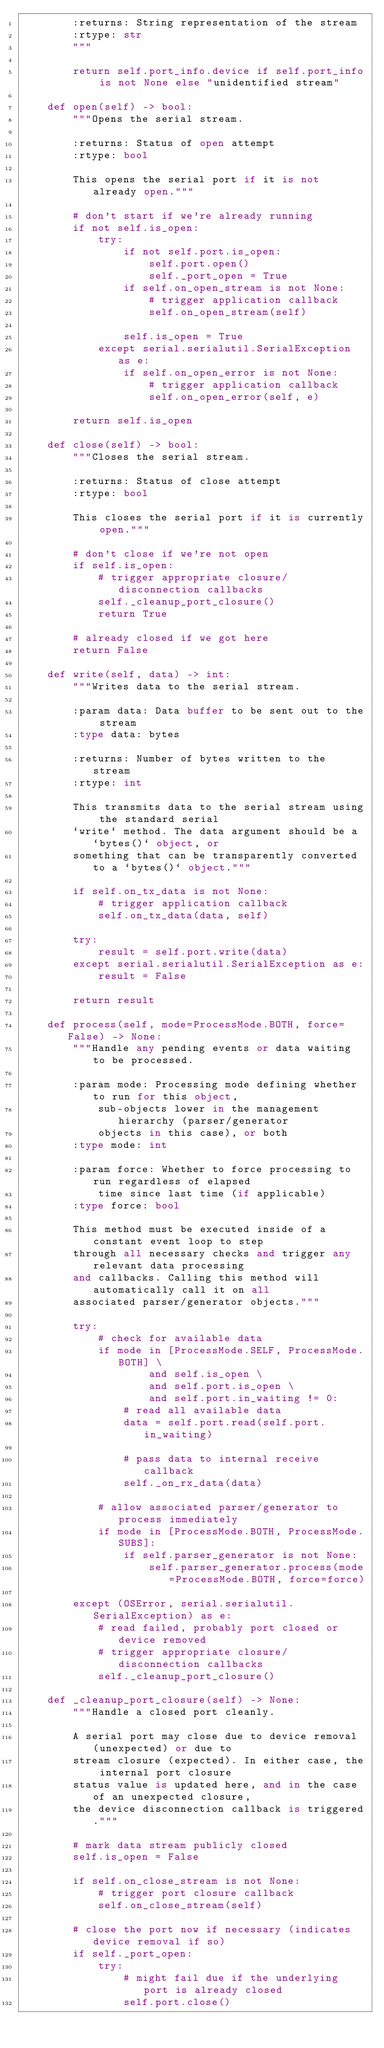Convert code to text. <code><loc_0><loc_0><loc_500><loc_500><_Python_>        :returns: String representation of the stream
        :rtype: str
        """

        return self.port_info.device if self.port_info is not None else "unidentified stream"

    def open(self) -> bool:
        """Opens the serial stream.

        :returns: Status of open attempt
        :rtype: bool

        This opens the serial port if it is not already open."""

        # don't start if we're already running
        if not self.is_open:
            try:
                if not self.port.is_open:
                    self.port.open()
                    self._port_open = True
                if self.on_open_stream is not None:
                    # trigger application callback
                    self.on_open_stream(self)

                self.is_open = True
            except serial.serialutil.SerialException as e:
                if self.on_open_error is not None:
                    # trigger application callback
                    self.on_open_error(self, e)

        return self.is_open

    def close(self) -> bool:
        """Closes the serial stream.

        :returns: Status of close attempt
        :rtype: bool

        This closes the serial port if it is currently open."""

        # don't close if we're not open
        if self.is_open:
            # trigger appropriate closure/disconnection callbacks
            self._cleanup_port_closure()
            return True

        # already closed if we got here
        return False

    def write(self, data) -> int:
        """Writes data to the serial stream.

        :param data: Data buffer to be sent out to the stream
        :type data: bytes

        :returns: Number of bytes written to the stream
        :rtype: int

        This transmits data to the serial stream using the standard serial
        `write` method. The data argument should be a `bytes()` object, or
        something that can be transparently converted to a `bytes()` object."""

        if self.on_tx_data is not None:
            # trigger application callback
            self.on_tx_data(data, self)

        try:
            result = self.port.write(data)
        except serial.serialutil.SerialException as e:
            result = False

        return result

    def process(self, mode=ProcessMode.BOTH, force=False) -> None:
        """Handle any pending events or data waiting to be processed.

        :param mode: Processing mode defining whether to run for this object,
            sub-objects lower in the management hierarchy (parser/generator
            objects in this case), or both
        :type mode: int

        :param force: Whether to force processing to run regardless of elapsed
            time since last time (if applicable)
        :type force: bool

        This method must be executed inside of a constant event loop to step
        through all necessary checks and trigger any relevant data processing
        and callbacks. Calling this method will automatically call it on all
        associated parser/generator objects."""

        try:
            # check for available data
            if mode in [ProcessMode.SELF, ProcessMode.BOTH] \
                    and self.is_open \
                    and self.port.is_open \
                    and self.port.in_waiting != 0:
                # read all available data
                data = self.port.read(self.port.in_waiting)

                # pass data to internal receive callback
                self._on_rx_data(data)

            # allow associated parser/generator to process immediately
            if mode in [ProcessMode.BOTH, ProcessMode.SUBS]:
                if self.parser_generator is not None:
                    self.parser_generator.process(mode=ProcessMode.BOTH, force=force)

        except (OSError, serial.serialutil.SerialException) as e:
            # read failed, probably port closed or device removed
            # trigger appropriate closure/disconnection callbacks
            self._cleanup_port_closure()

    def _cleanup_port_closure(self) -> None:
        """Handle a closed port cleanly.

        A serial port may close due to device removal (unexpected) or due to
        stream closure (expected). In either case, the internal port closure
        status value is updated here, and in the case of an unexpected closure,
        the device disconnection callback is triggered."""

        # mark data stream publicly closed
        self.is_open = False

        if self.on_close_stream is not None:
            # trigger port closure callback
            self.on_close_stream(self)

        # close the port now if necessary (indicates device removal if so)
        if self._port_open:
            try:
                # might fail due if the underlying port is already closed
                self.port.close()</code> 